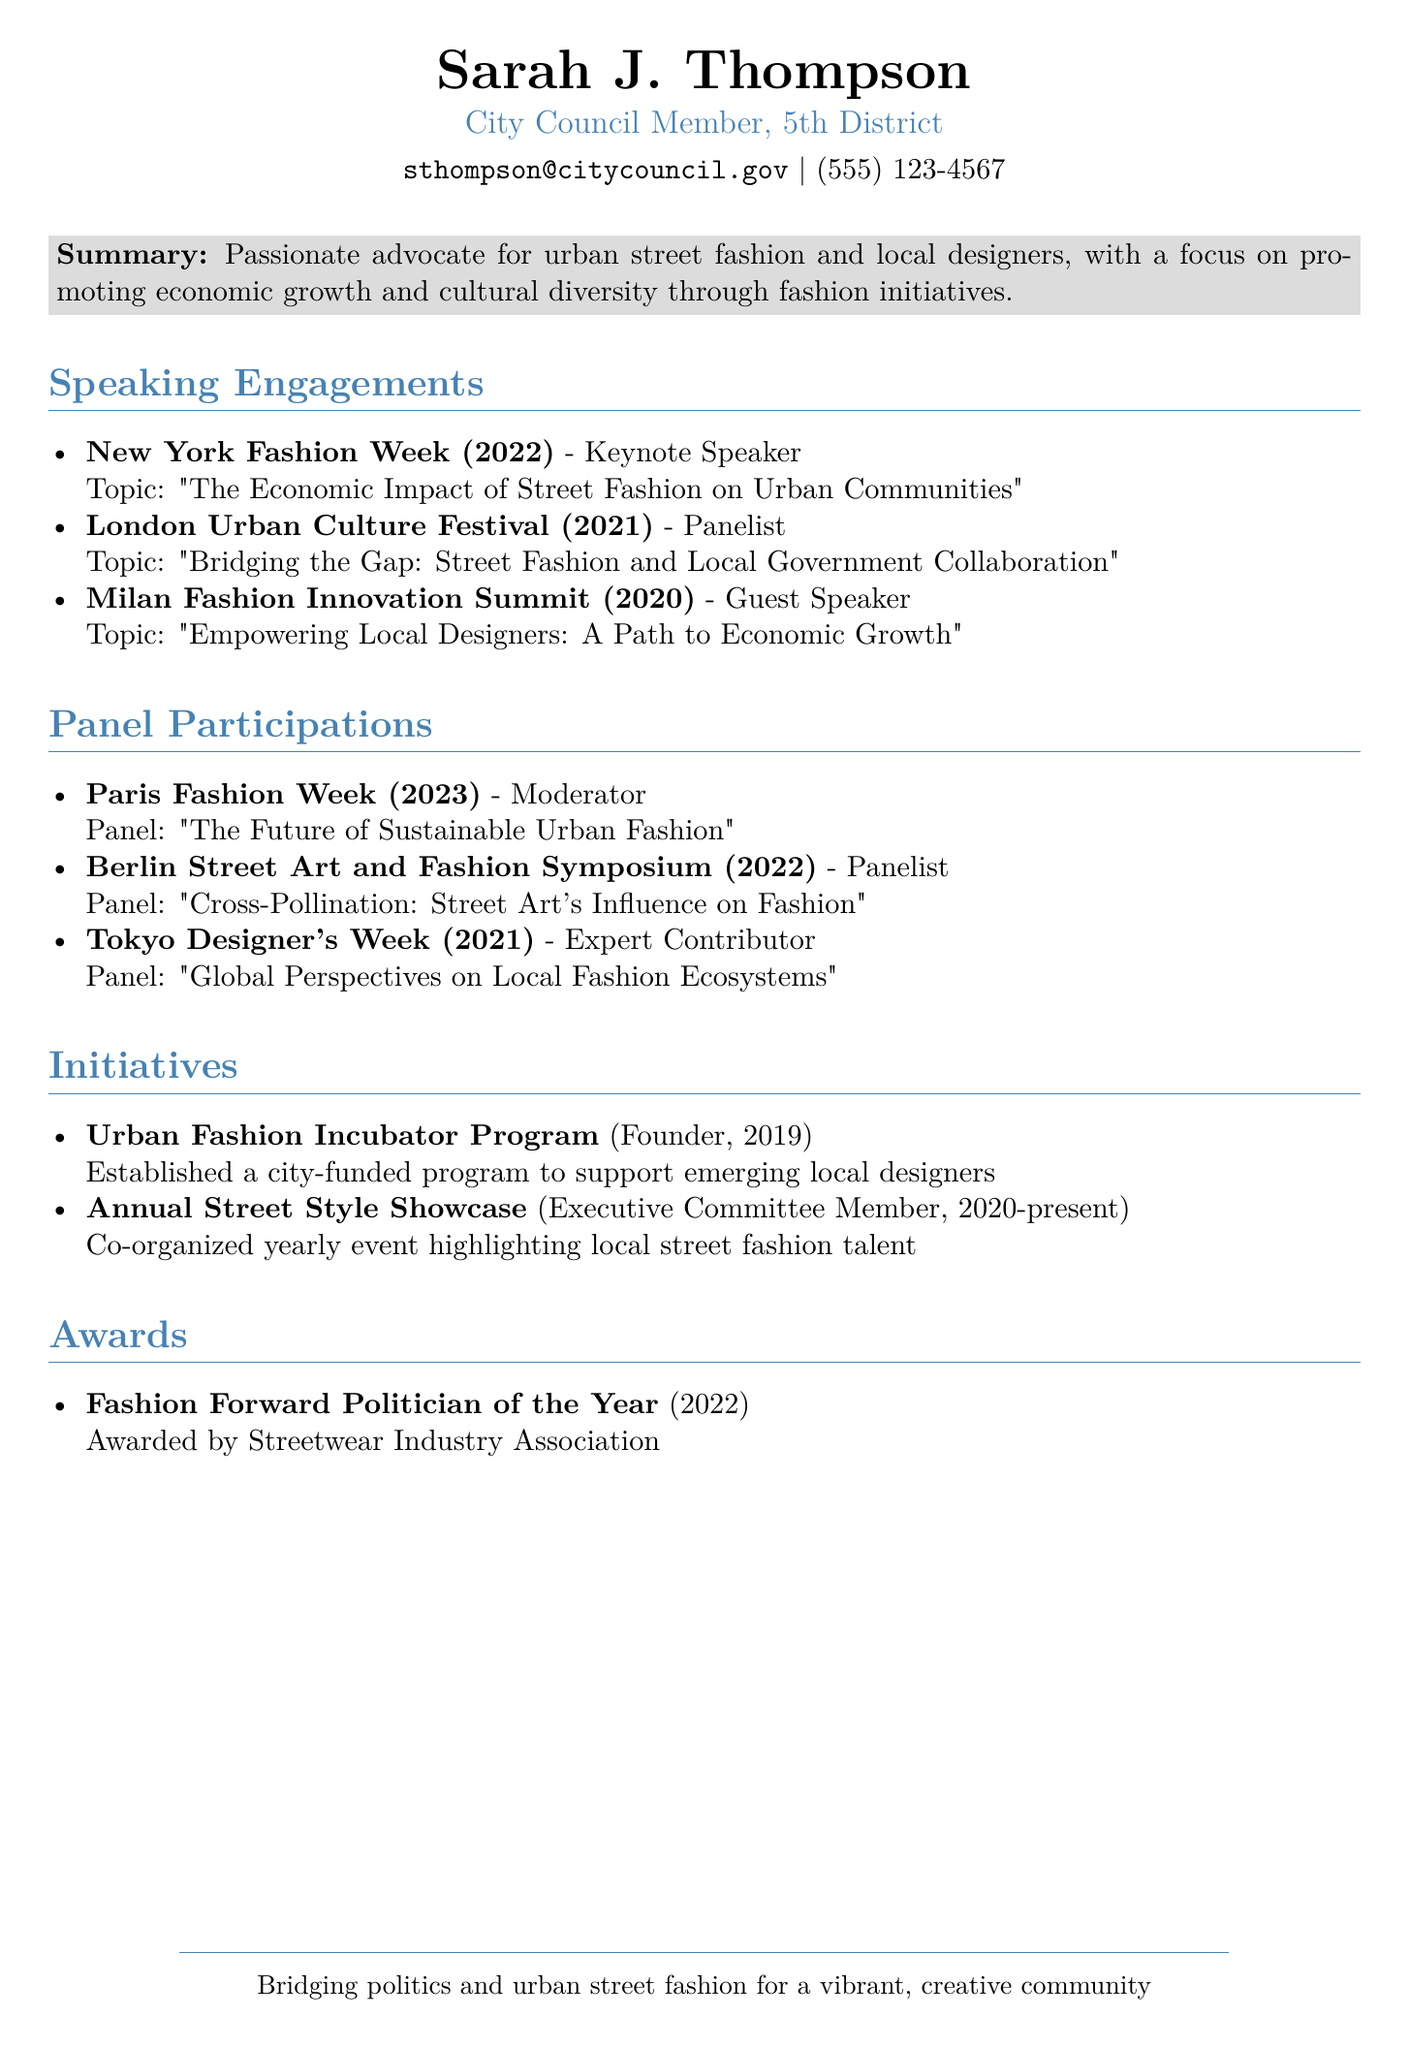what is the name of the person in the CV? The name is listed at the top of the document as Sarah J. Thompson.
Answer: Sarah J. Thompson what role did Sarah J. Thompson have at New York Fashion Week? The role is specified under speaking engagements as Keynote Speaker.
Answer: Keynote Speaker in what year did Sarah J. Thompson establish the Urban Fashion Incubator Program? The year is indicated in the initiatives section as 2019.
Answer: 2019 which award did Sarah J. Thompson receive in 2022? The award is mentioned in the awards section as Fashion Forward Politician of the Year.
Answer: Fashion Forward Politician of the Year how many speaking engagements are listed in the document? The document lists three speaking engagements under a specific section.
Answer: 3 who was a panelist at the Berlin Street Art and Fashion Symposium? The role is defined in the panel participations section identifying Sarah J. Thompson as a panelist.
Answer: Sarah J. Thompson what is the topic discussed by Sarah J. Thompson at the Milan Fashion Innovation Summit? The topic is provided in the speaking engagements section as Empowering Local Designers: A Path to Economic Growth.
Answer: Empowering Local Designers: A Path to Economic Growth how long has Sarah J. Thompson been an Executive Committee Member for the Annual Street Style Showcase? The duration is noted as from 2020 to present, indicating a timespan of at least three years.
Answer: 2020-present what is the main focus of Sarah J. Thompson's initiatives according to the summary? The summary highlights the support of economic growth and cultural diversity through fashion initiatives.
Answer: Economic growth and cultural diversity 